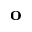Convert formula to latex. <formula><loc_0><loc_0><loc_500><loc_500>o</formula> 